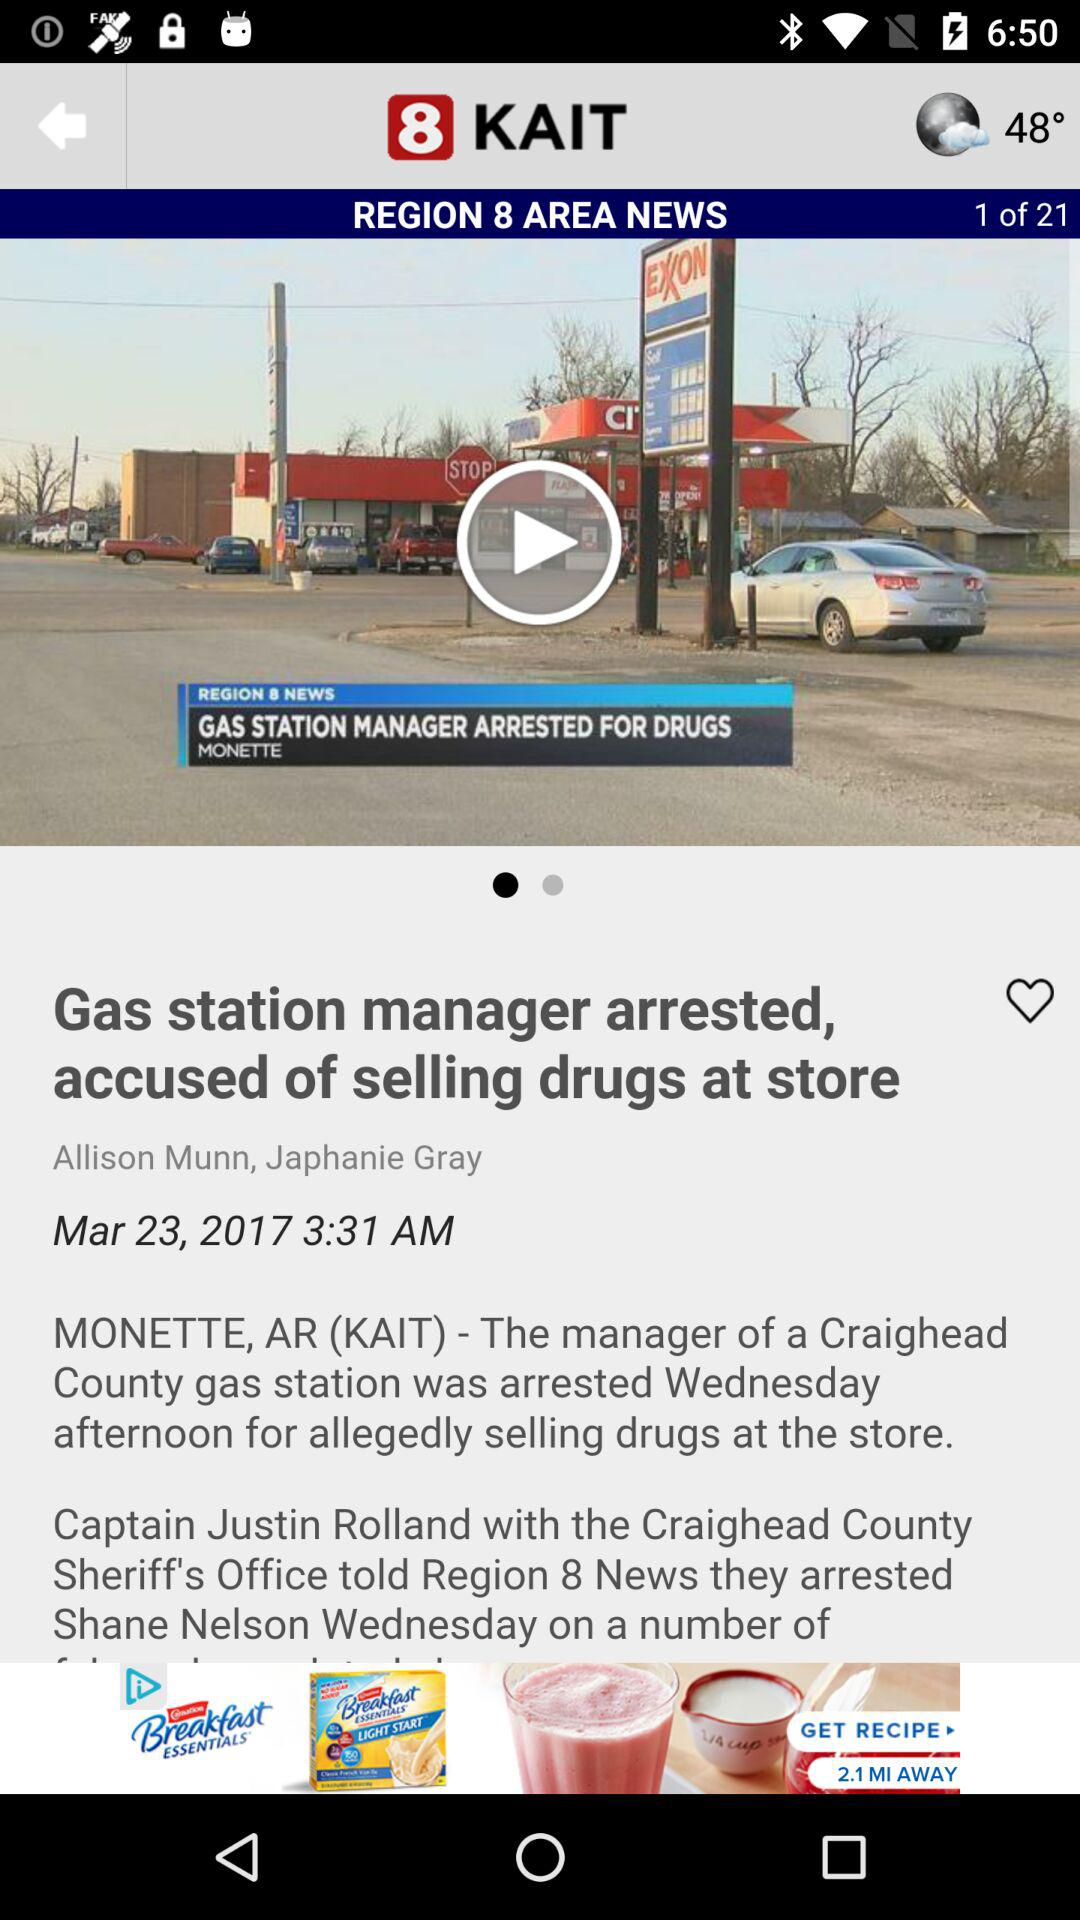What is the publication date and time? The publication date and time is March 23, 2017 at 3:31 AM. 